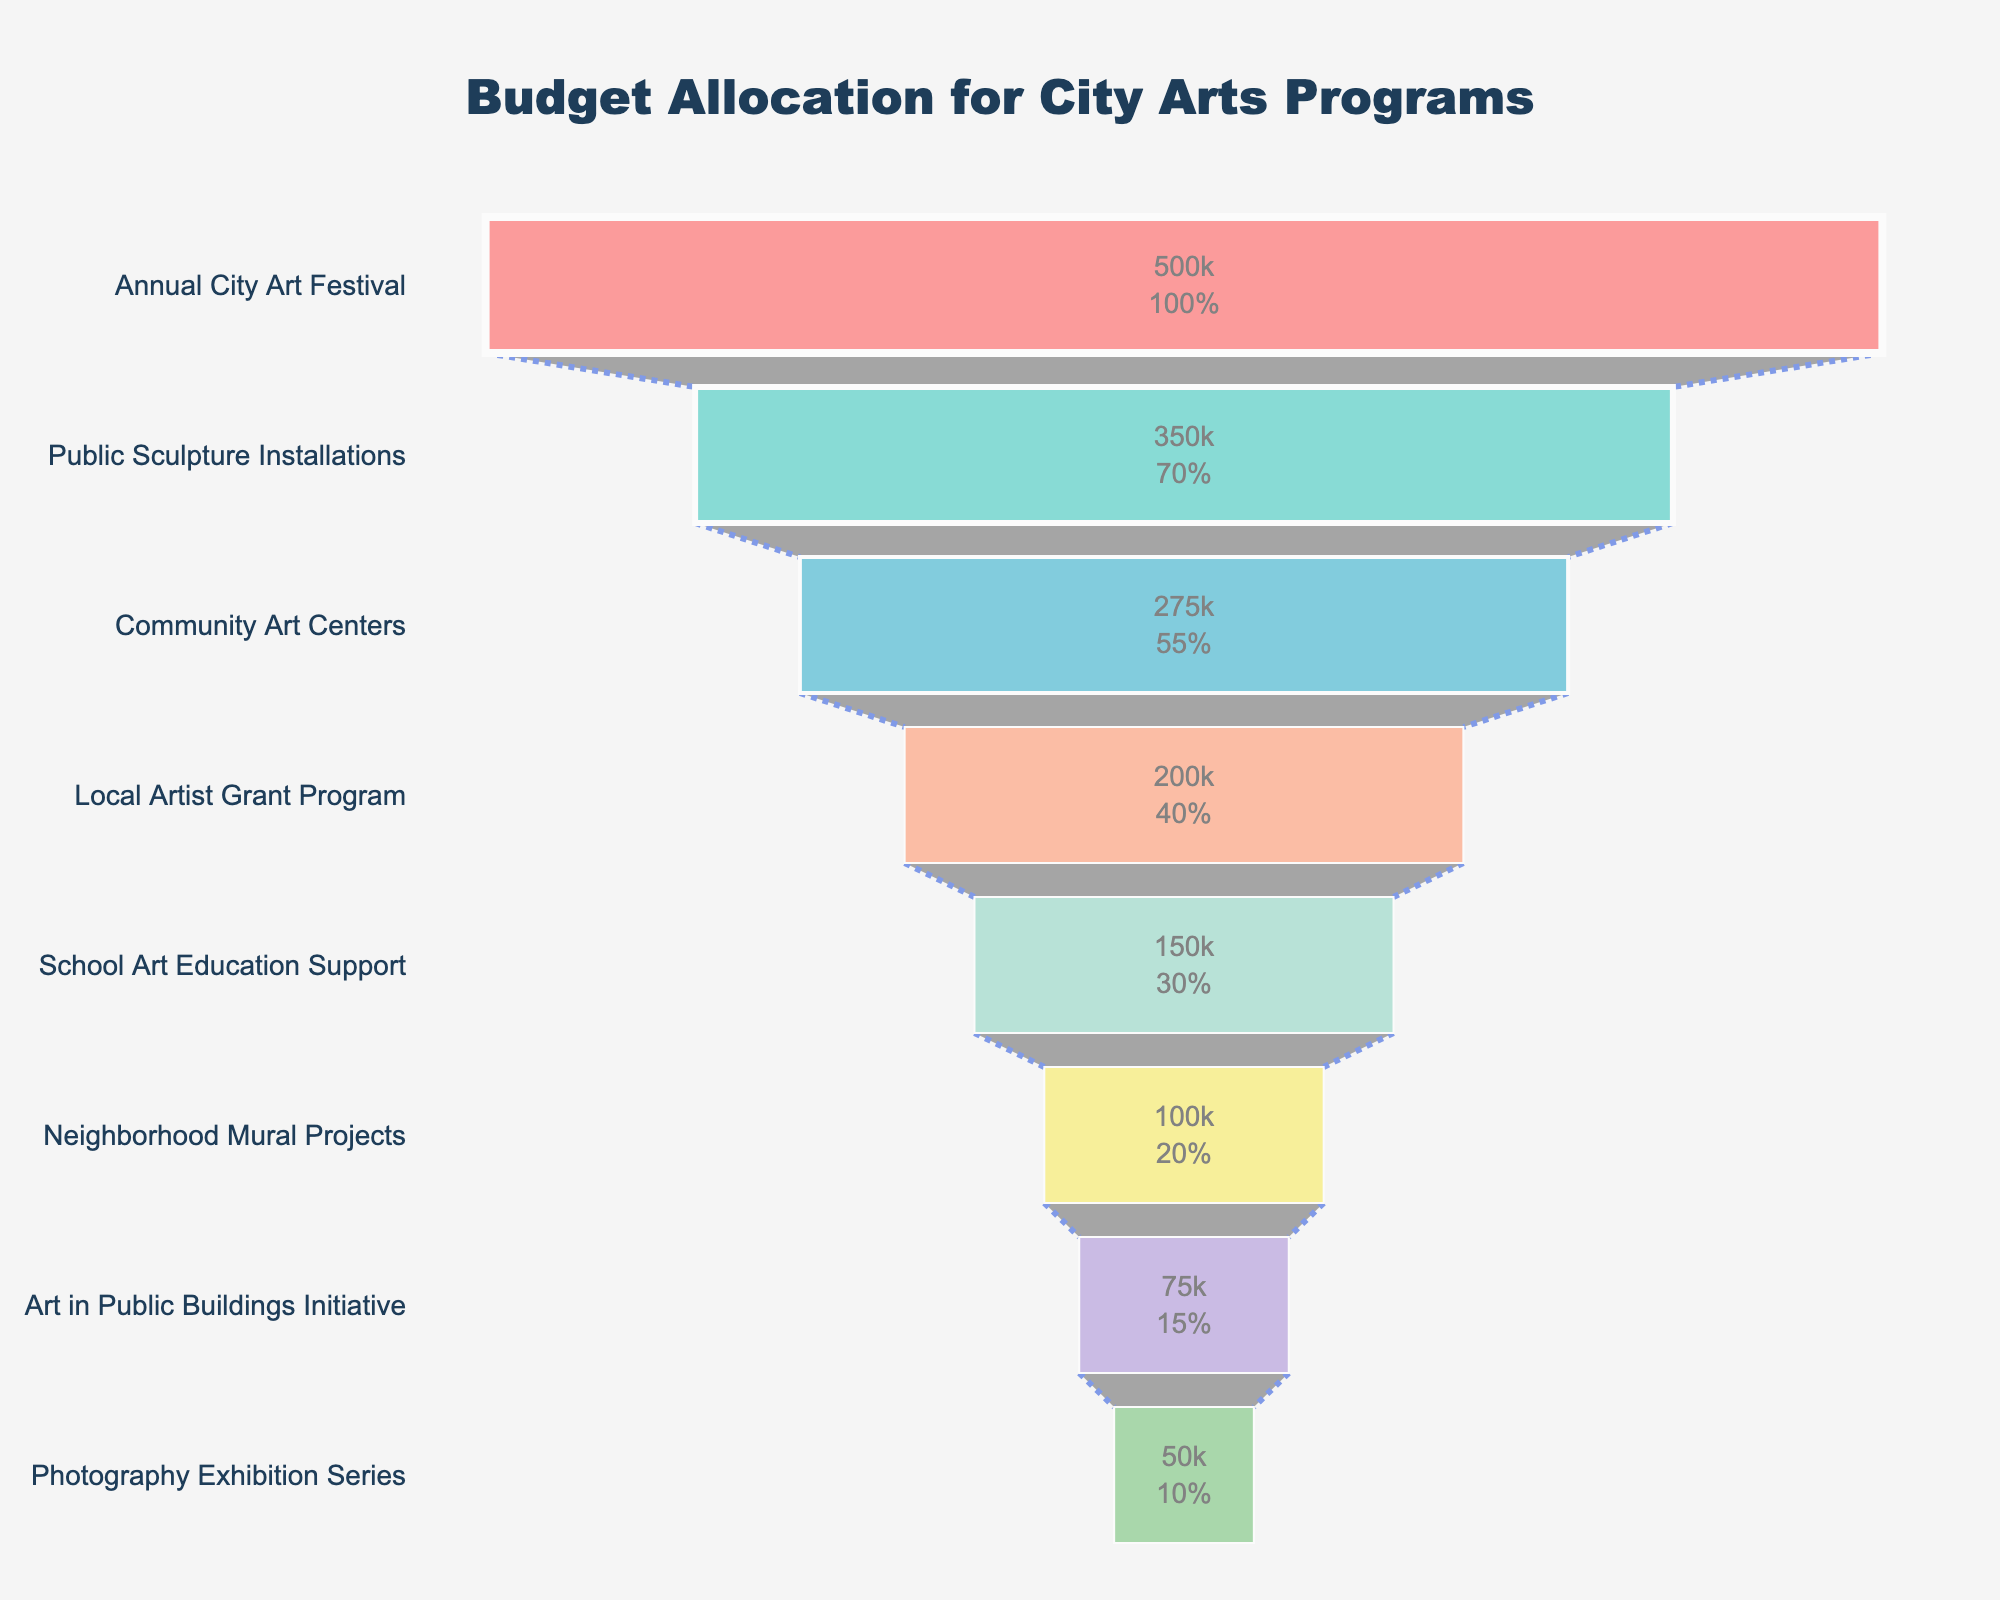What is the title of the funnel chart? The title of the funnel chart is prominently displayed at the top of the chart.
Answer: Budget Allocation for City Arts Programs Which program has the highest budget allocation and by how much? By looking at the top of the funnel, we can see which program has the highest budget allocation along with the budget amount.
Answer: Annual City Art Festival, $500,000 How many programs have a budget allocation below $100,000? By referencing the lower part of the funnel, we can count the programs with allocated funds below $100,000.
Answer: Three What is the total budget allocated for city arts programs? Add the budget allocations of all the programs listed in the funnel chart: $500,000 + $350,000 + $275,000 + $200,000 + $150,000 + $100,000 + $75,000 + $50,000 = $1,700,000
Answer: $1,700,000 Comparing the City's Art Festival and Community Art Centers, how much more funding does the former receive? Subtract the budget allocation for Community Art Centers from that of the Annual City Art Festival: $500,000 - $275,000 = $225,000
Answer: $225,000 Which programs have a budget allocation closest to the median value, and what is that value? First, list the budgets in ascending order and find the middle value(s): $50,000, $75,000, $100,000, $150,000, $200,000, $275,000, $350,000, $500,000. The median is the average of the 4th and 5th values: ($150,000 + $200,000) / 2 = $175,000. The closest allocations are School Art Education Support ($150,000) and Local Artist Grant Program ($200,000).
Answer: $175,000; School Art Education Support and Local Artist Grant Program What percentage of the total budget is allocated to the Public Sculpture Installations? Calculate the percentage: ($350,000 / $1,700,000) * 100 ≈ 20.59%
Answer: Approximately 20.59% How much less funding does the Photography Exhibition Series receive compared to the Neighborhood Mural Projects? Subtract the budget for the Photography Exhibition Series from that for the Neighborhood Mural Projects: $100,000 - $50,000 = $50,000
Answer: $50,000 What is the total budget for the top three initiatives? Add the budget allocations for the top three programs: $500,000 + $350,000 + $275,000 = $1,125,000
Answer: $1,125,000 Which initiative ranks fourth in terms of budget allocation, and what is the amount? Identify the fourth program in the funnel chart from the top: Local Artist Grant Program with a budget of $200,000.
Answer: Local Artist Grant Program, $200,000 